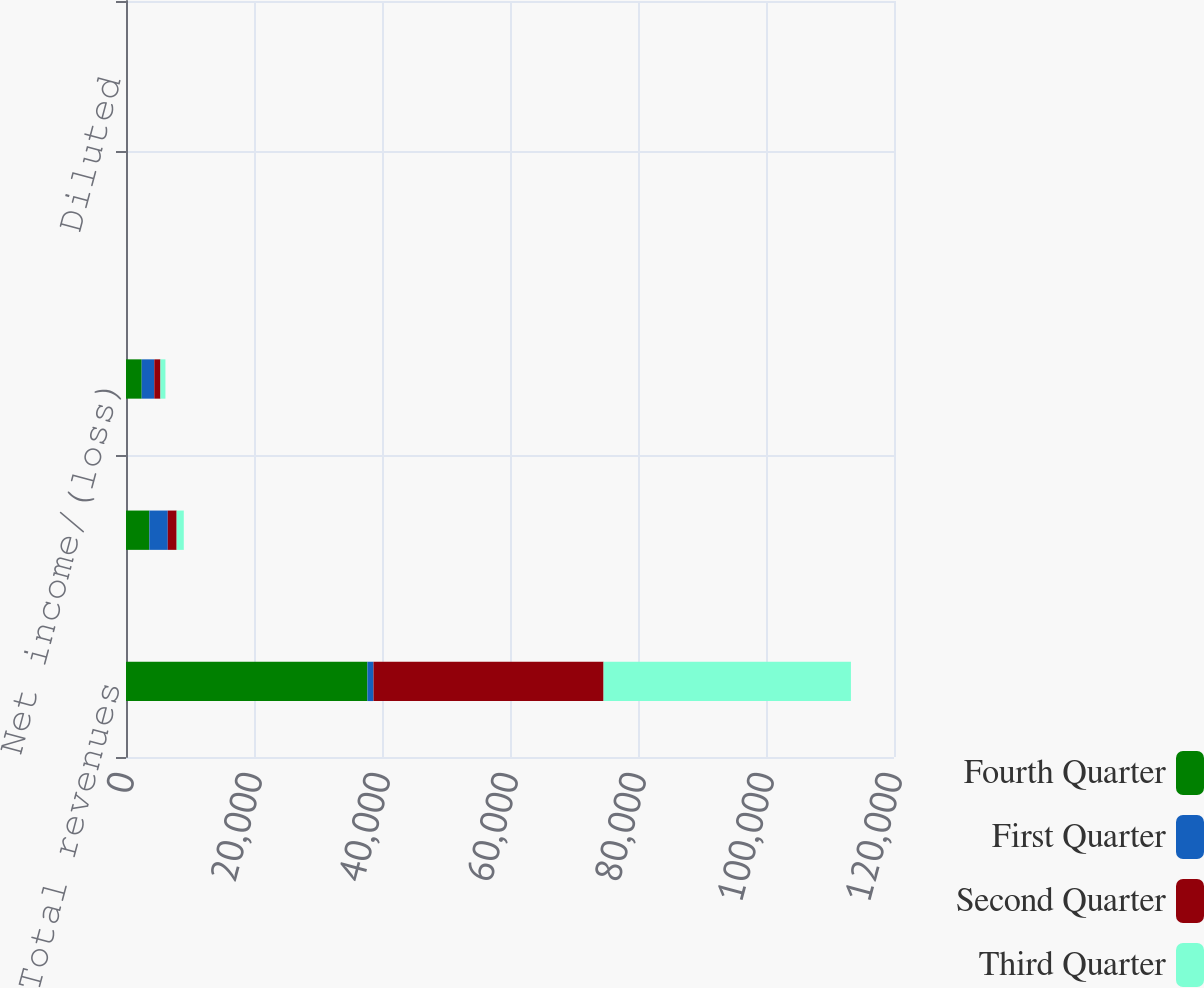Convert chart to OTSL. <chart><loc_0><loc_0><loc_500><loc_500><stacked_bar_chart><ecel><fcel>Total revenues<fcel>Income/(Loss) before income<fcel>Net income/(loss)<fcel>Basic<fcel>Diluted<nl><fcel>Fourth Quarter<fcel>37718<fcel>3651<fcel>2452<fcel>0.62<fcel>0.61<nl><fcel>First Quarter<fcel>957<fcel>2875<fcel>1970<fcel>0.5<fcel>0.49<nl><fcel>Second Quarter<fcel>35943<fcel>1387<fcel>957<fcel>0.24<fcel>0.24<nl><fcel>Third Quarter<fcel>38654<fcel>1117<fcel>783<fcel>0.2<fcel>0.2<nl></chart> 